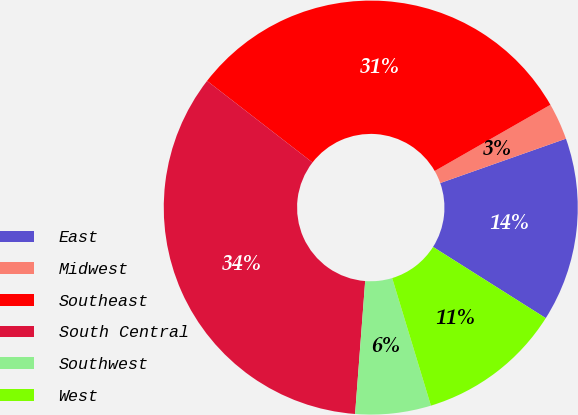Convert chart to OTSL. <chart><loc_0><loc_0><loc_500><loc_500><pie_chart><fcel>East<fcel>Midwest<fcel>Southeast<fcel>South Central<fcel>Southwest<fcel>West<nl><fcel>14.37%<fcel>2.87%<fcel>31.25%<fcel>34.28%<fcel>5.9%<fcel>11.34%<nl></chart> 